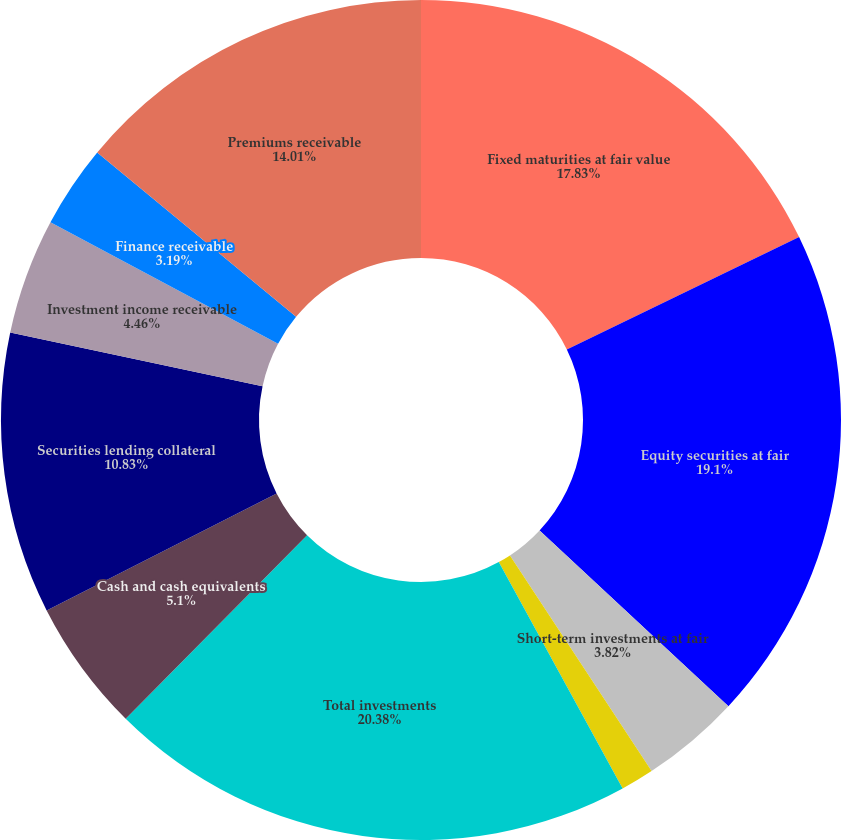<chart> <loc_0><loc_0><loc_500><loc_500><pie_chart><fcel>Fixed maturities at fair value<fcel>Equity securities at fair<fcel>Short-term investments at fair<fcel>Other invested assets<fcel>Total investments<fcel>Cash and cash equivalents<fcel>Securities lending collateral<fcel>Investment income receivable<fcel>Finance receivable<fcel>Premiums receivable<nl><fcel>17.83%<fcel>19.1%<fcel>3.82%<fcel>1.28%<fcel>20.38%<fcel>5.1%<fcel>10.83%<fcel>4.46%<fcel>3.19%<fcel>14.01%<nl></chart> 